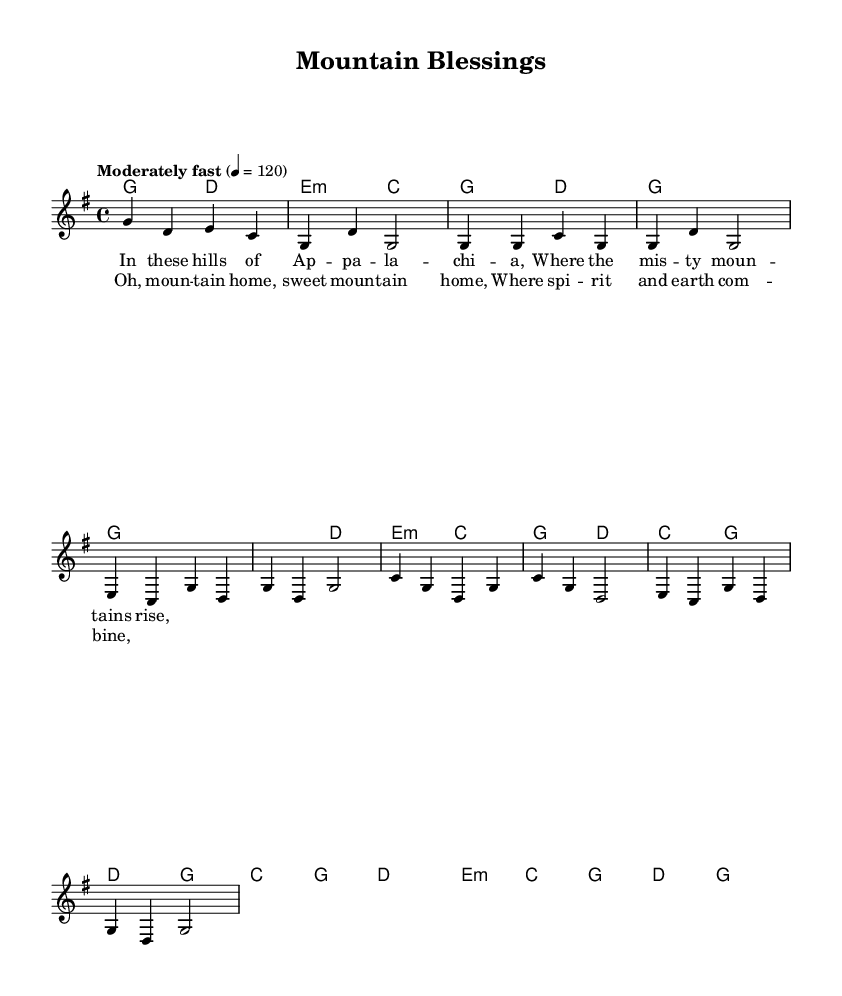What is the key signature of this music? The key signature indicated in the music is G major, which contains one sharp (F#). This is determined by looking at the key signature symbol placed at the beginning of the staff, next to the treble clef.
Answer: G major What is the time signature of this music? The time signature is 4/4, as shown at the beginning of the piece in the time signature indication. It indicates that there are four beats in a measure and a quarter note gets one beat.
Answer: 4/4 What is the tempo marking of this piece? The tempo marking "Moderately fast" indicates that the piece should be played at a speed of 120 beats per minute. This tempo is found directly below the staff, guiding the performance speed.
Answer: Moderately fast How many measures are in the chorus section? The chorus section consists of four measures. By counting the individual segments separated by vertical lines (bar lines), you can easily differentiate the various sections of the music.
Answer: 4 What is the mood conveyed by the lyrics of the first verse? The lyrics suggest a mood of nostalgia and reverence for the Appalachian mountains, as they describe the natural beauty of the region. The imagery of "misty mountains" invokes a serene and sacred feeling, aligning well with the spiritual theme of the piece.
Answer: Nostalgia What are the first two chords in the harmony section? The first two chords listed in the harmony section are G major and D major. This can be seen at the beginning of the harmony part, where the chords are notated above the melody to guide harmonic accompaniment.
Answer: G and D Which instrument is indicated to play the melody? The melody is indicated to be played by a voice, as noted by the label "lead" next to the voice in the score section. This suggests that the lead vocal part carries the main melody of the song.
Answer: Voice 